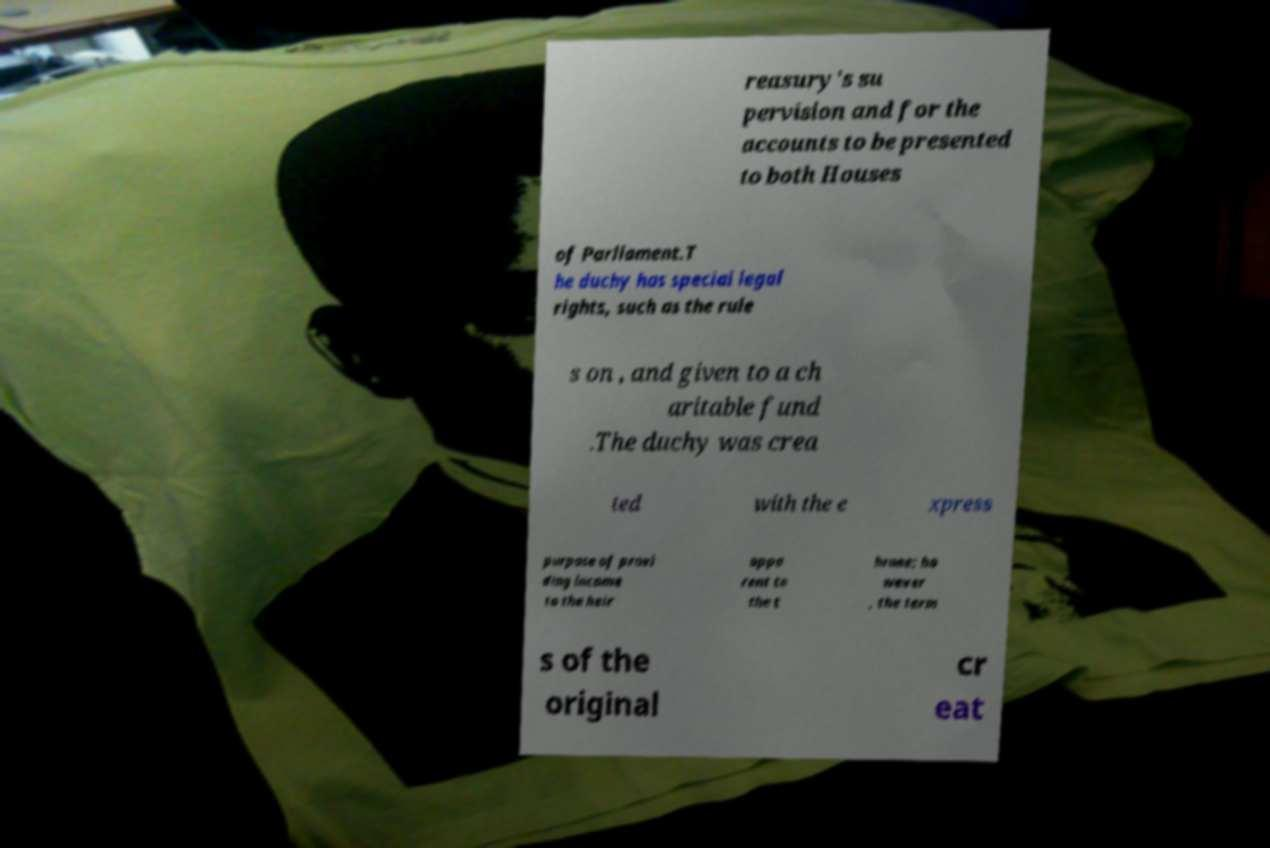Please read and relay the text visible in this image. What does it say? reasury's su pervision and for the accounts to be presented to both Houses of Parliament.T he duchy has special legal rights, such as the rule s on , and given to a ch aritable fund .The duchy was crea ted with the e xpress purpose of provi ding income to the heir appa rent to the t hrone; ho wever , the term s of the original cr eat 